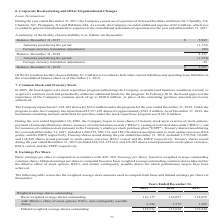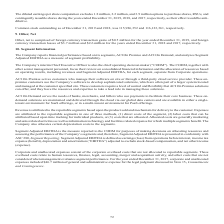According to Aci Worldwide's financial document, How were basic earnings per share computed by the company? in accordance with ASC 260, Earnings per Share, based on weighted average outstanding common shares.. The document states: "Basic earnings per share is computed in accordance with ASC 260, Earnings per Share, based on weighted average outstanding common shares. Diluted earn..." Also, How were diluted earnings per share computed by the company? based on basic weighted average outstanding common shares adjusted for the dilutive effect of stock options, RSUs, and certain contingently issuable shares for which performance targets have been achieved.. The document states: "mon shares. Diluted earnings per share is computed based on basic weighted average outstanding common shares adjusted for the dilutive effect of stock..." Also, What was the basic weighted average shares outstanding in 2019? According to the financial document, 116,175 (in thousands). The relevant text states: "Basic weighted average shares outstanding 116,175 116,057 118,059..." Also, can you calculate: What was the change in Basic weighted average shares outstanding between 2018 and 2019? Based on the calculation: 116,175-116,057, the result is 118 (in thousands). This is based on the information: "Basic weighted average shares outstanding 116,175 116,057 118,059 Basic weighted average shares outstanding 116,175 116,057 118,059..." The key data points involved are: 116,057, 116,175. Also, can you calculate: What was the change in Basic weighted average shares outstanding between 2017 and 2018? Based on the calculation: 116,057-118,059, the result is -2002 (in thousands). This is based on the information: "ighted average shares outstanding 116,175 116,057 118,059 Basic weighted average shares outstanding 116,175 116,057 118,059..." The key data points involved are: 116,057, 118,059. Also, can you calculate: What was the percentage change in Diluted weighted average shares outstanding between 2018 and 2019? To answer this question, I need to perform calculations using the financial data. The calculation is: (118,571-117,632)/117,632, which equals 0.8 (percentage). This is based on the information: "Diluted weighted average shares outstanding 118,571 117,632 119,444 luted weighted average shares outstanding 118,571 117,632 119,444..." The key data points involved are: 117,632, 118,571. 